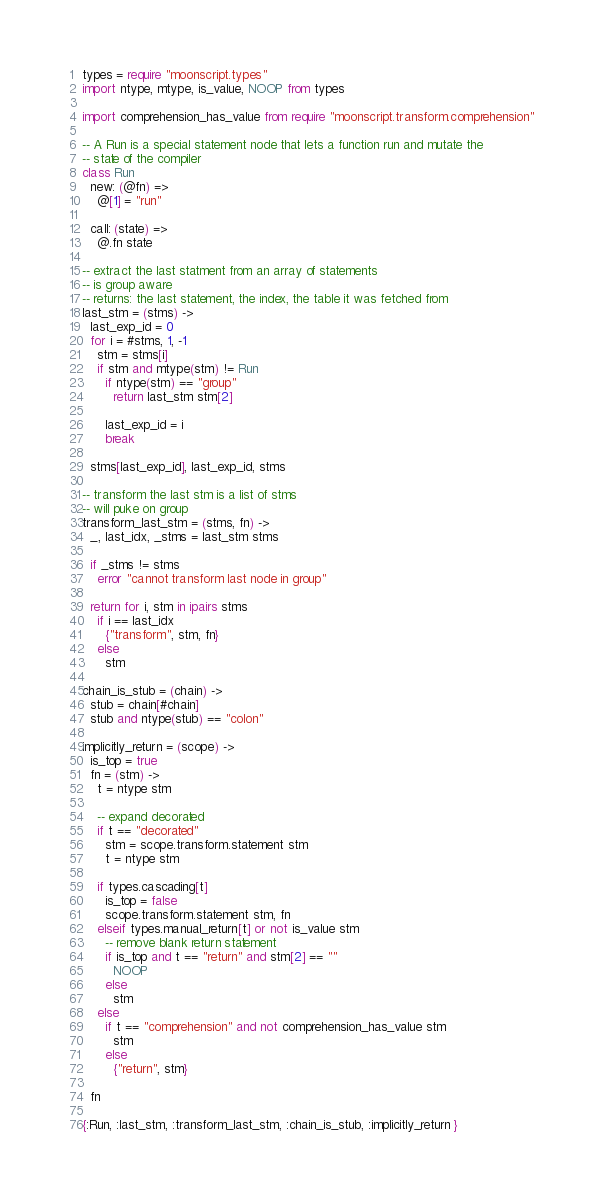Convert code to text. <code><loc_0><loc_0><loc_500><loc_500><_MoonScript_>
types = require "moonscript.types"
import ntype, mtype, is_value, NOOP from types

import comprehension_has_value from require "moonscript.transform.comprehension"

-- A Run is a special statement node that lets a function run and mutate the
-- state of the compiler
class Run
  new: (@fn) =>
    @[1] = "run"

  call: (state) =>
    @.fn state

-- extract the last statment from an array of statements
-- is group aware
-- returns: the last statement, the index, the table it was fetched from
last_stm = (stms) ->
  last_exp_id = 0
  for i = #stms, 1, -1
    stm = stms[i]
    if stm and mtype(stm) != Run
      if ntype(stm) == "group"
        return last_stm stm[2]

      last_exp_id = i
      break

  stms[last_exp_id], last_exp_id, stms

-- transform the last stm is a list of stms
-- will puke on group
transform_last_stm = (stms, fn) ->
  _, last_idx, _stms = last_stm stms

  if _stms != stms
    error "cannot transform last node in group"

  return for i, stm in ipairs stms
    if i == last_idx
      {"transform", stm, fn}
    else
      stm

chain_is_stub = (chain) ->
  stub = chain[#chain]
  stub and ntype(stub) == "colon"

implicitly_return = (scope) ->
  is_top = true
  fn = (stm) ->
    t = ntype stm

    -- expand decorated
    if t == "decorated"
      stm = scope.transform.statement stm
      t = ntype stm

    if types.cascading[t]
      is_top = false
      scope.transform.statement stm, fn
    elseif types.manual_return[t] or not is_value stm
      -- remove blank return statement
      if is_top and t == "return" and stm[2] == ""
        NOOP
      else
        stm
    else
      if t == "comprehension" and not comprehension_has_value stm
        stm
      else
        {"return", stm}

  fn

{:Run, :last_stm, :transform_last_stm, :chain_is_stub, :implicitly_return }

</code> 